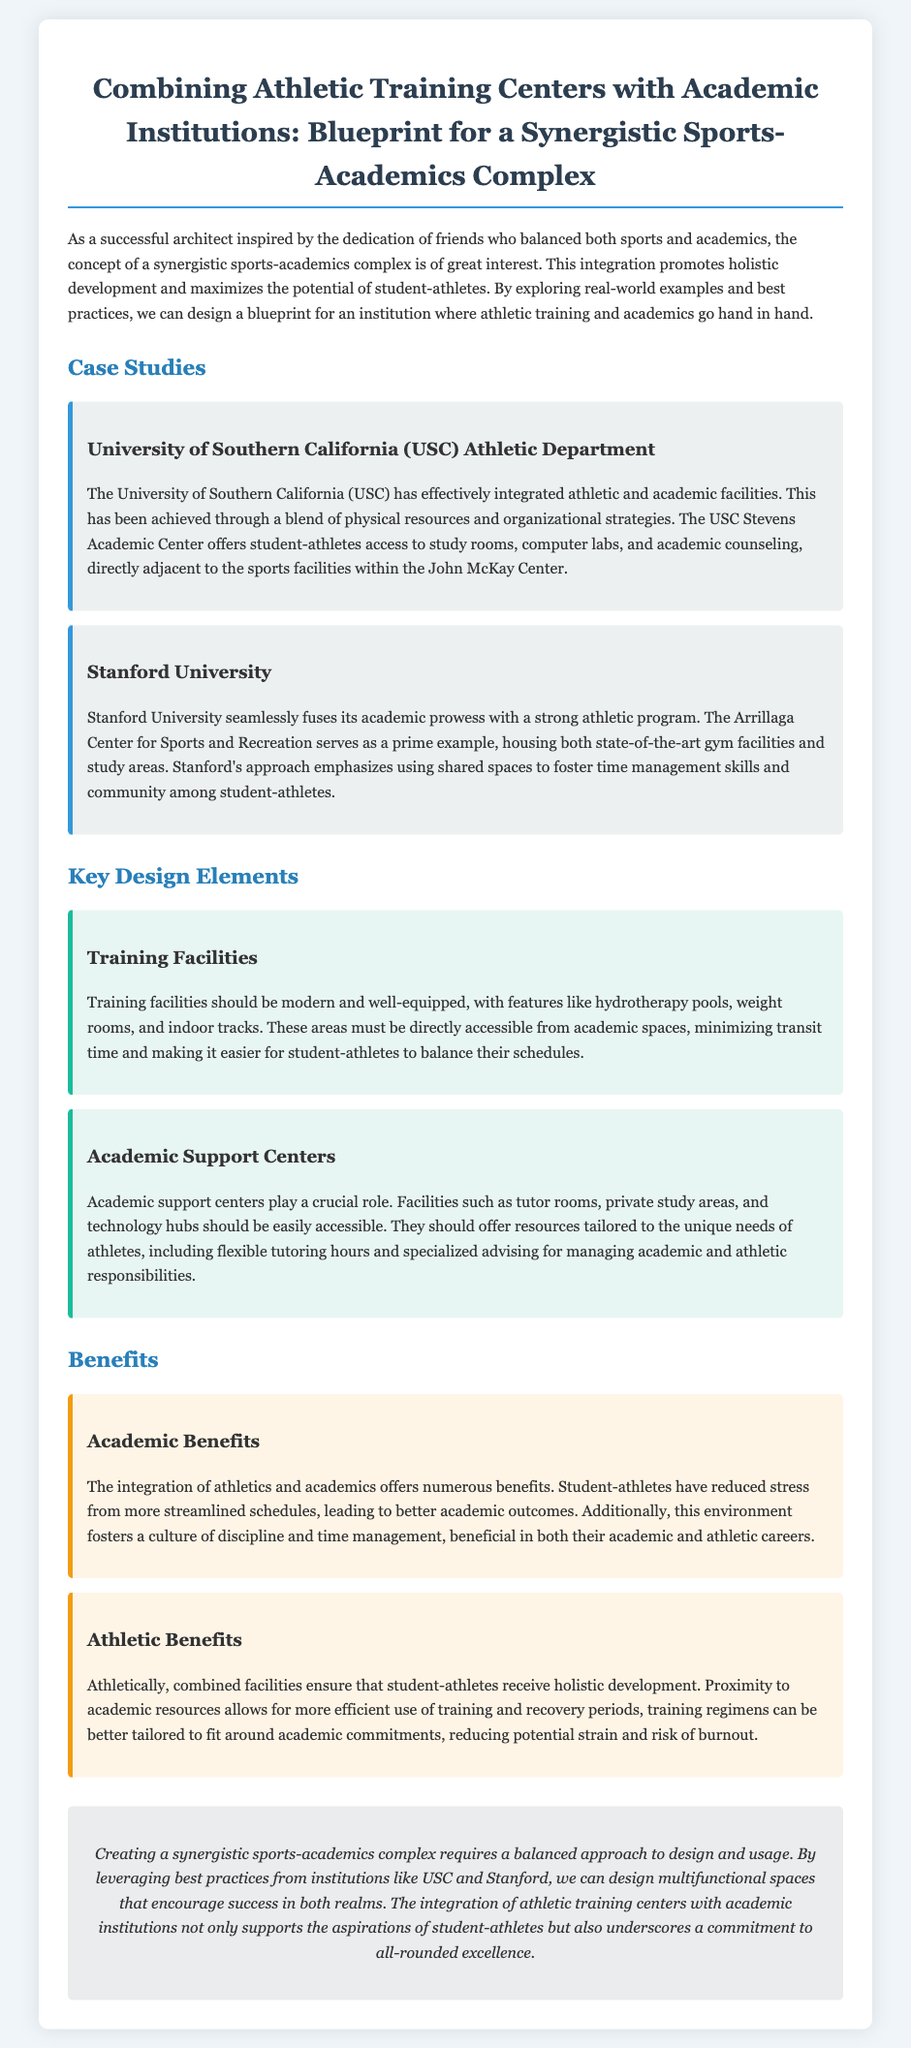What university is featured for its athletic department integration? The document discusses the University of Southern California (USC) as a case study for integrating athletic and academic facilities.
Answer: University of Southern California (USC) What is the name of the facility that offers academic support at USC? The USC Stevens Academic Center provides academic support specifically for student-athletes.
Answer: USC Stevens Academic Center What is a key feature of training facilities mentioned in the document? The document states that modern and well-equipped training facilities should include hydrotherapy pools.
Answer: Hydrotherapy pools What type of academic support facilities are mentioned? The document highlights tutor rooms and private study areas as essential academic support facilities for student-athletes.
Answer: Tutor rooms What is one academic benefit of integrating athletics and academics? According to the document, a culture of discipline and time management is a significant academic benefit of this integration.
Answer: Discipline and time management Which university is noted for its Arrillaga Center for Sports and Recreation? Stanford University is mentioned as having the Arrillaga Center, which blends academic and athletic facilities.
Answer: Stanford University What is the main purpose of a synergistic sports-academics complex? The document explains that the main purpose is to promote holistic development among student-athletes.
Answer: Holistic development How does the document describe the design approach for the complex? It states that a balanced approach to design and usage is necessary for an effective synergistic sports-academics complex.
Answer: Balanced approach 